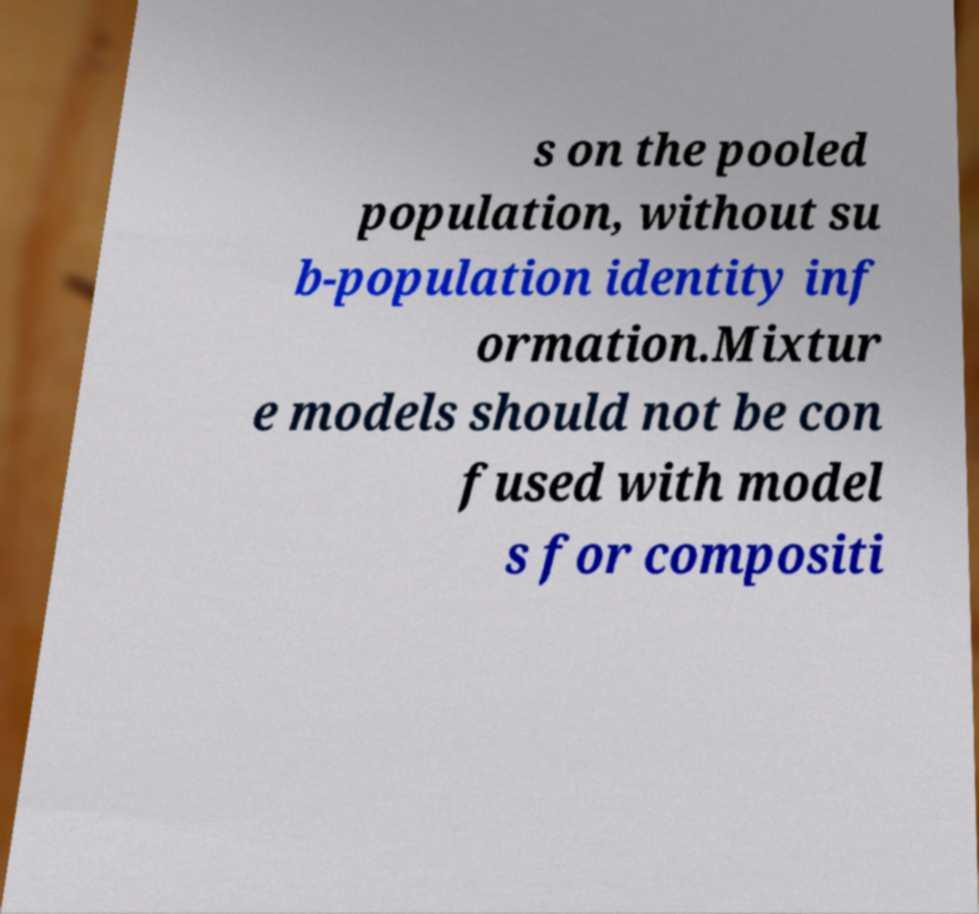For documentation purposes, I need the text within this image transcribed. Could you provide that? s on the pooled population, without su b-population identity inf ormation.Mixtur e models should not be con fused with model s for compositi 